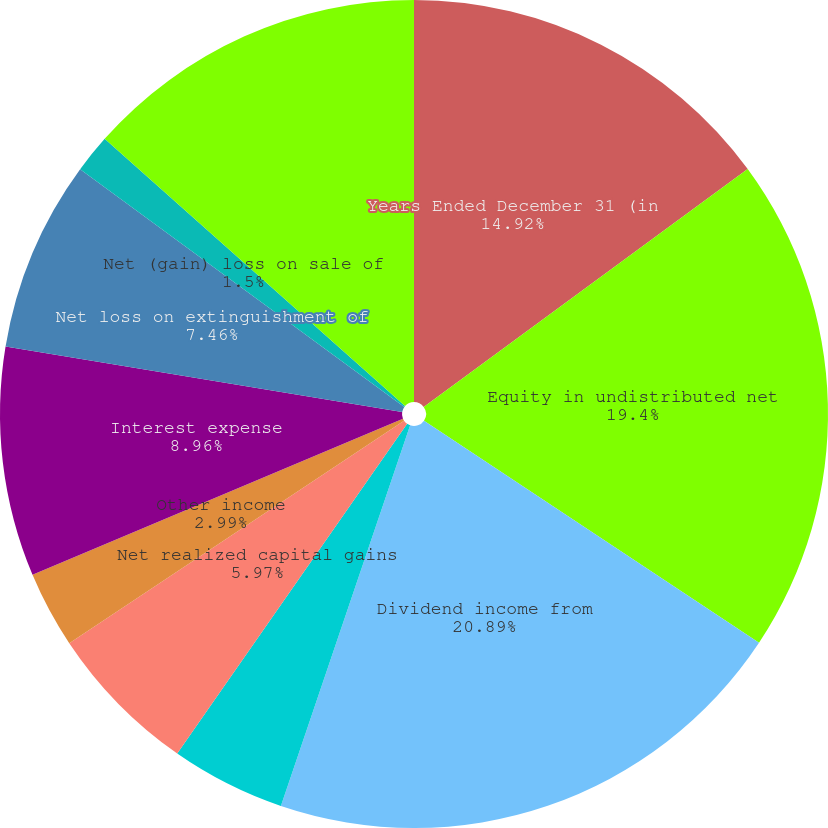Convert chart. <chart><loc_0><loc_0><loc_500><loc_500><pie_chart><fcel>Years Ended December 31 (in<fcel>Equity in undistributed net<fcel>Dividend income from<fcel>Interest income<fcel>Net realized capital gains<fcel>Other income<fcel>Interest expense<fcel>Net loss on extinguishment of<fcel>Net (gain) loss on sale of<fcel>Other expenses<nl><fcel>14.92%<fcel>19.4%<fcel>20.89%<fcel>4.48%<fcel>5.97%<fcel>2.99%<fcel>8.96%<fcel>7.46%<fcel>1.5%<fcel>13.43%<nl></chart> 